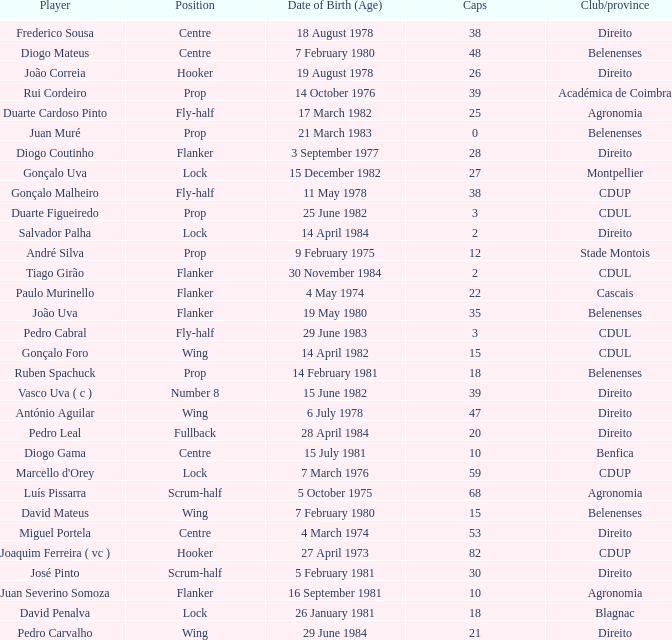Could you parse the entire table? {'header': ['Player', 'Position', 'Date of Birth (Age)', 'Caps', 'Club/province'], 'rows': [['Frederico Sousa', 'Centre', '18 August 1978', '38', 'Direito'], ['Diogo Mateus', 'Centre', '7 February 1980', '48', 'Belenenses'], ['João Correia', 'Hooker', '19 August 1978', '26', 'Direito'], ['Rui Cordeiro', 'Prop', '14 October 1976', '39', 'Académica de Coimbra'], ['Duarte Cardoso Pinto', 'Fly-half', '17 March 1982', '25', 'Agronomia'], ['Juan Muré', 'Prop', '21 March 1983', '0', 'Belenenses'], ['Diogo Coutinho', 'Flanker', '3 September 1977', '28', 'Direito'], ['Gonçalo Uva', 'Lock', '15 December 1982', '27', 'Montpellier'], ['Gonçalo Malheiro', 'Fly-half', '11 May 1978', '38', 'CDUP'], ['Duarte Figueiredo', 'Prop', '25 June 1982', '3', 'CDUL'], ['Salvador Palha', 'Lock', '14 April 1984', '2', 'Direito'], ['André Silva', 'Prop', '9 February 1975', '12', 'Stade Montois'], ['Tiago Girão', 'Flanker', '30 November 1984', '2', 'CDUL'], ['Paulo Murinello', 'Flanker', '4 May 1974', '22', 'Cascais'], ['João Uva', 'Flanker', '19 May 1980', '35', 'Belenenses'], ['Pedro Cabral', 'Fly-half', '29 June 1983', '3', 'CDUL'], ['Gonçalo Foro', 'Wing', '14 April 1982', '15', 'CDUL'], ['Ruben Spachuck', 'Prop', '14 February 1981', '18', 'Belenenses'], ['Vasco Uva ( c )', 'Number 8', '15 June 1982', '39', 'Direito'], ['António Aguilar', 'Wing', '6 July 1978', '47', 'Direito'], ['Pedro Leal', 'Fullback', '28 April 1984', '20', 'Direito'], ['Diogo Gama', 'Centre', '15 July 1981', '10', 'Benfica'], ["Marcello d'Orey", 'Lock', '7 March 1976', '59', 'CDUP'], ['Luís Pissarra', 'Scrum-half', '5 October 1975', '68', 'Agronomia'], ['David Mateus', 'Wing', '7 February 1980', '15', 'Belenenses'], ['Miguel Portela', 'Centre', '4 March 1974', '53', 'Direito'], ['Joaquim Ferreira ( vc )', 'Hooker', '27 April 1973', '82', 'CDUP'], ['José Pinto', 'Scrum-half', '5 February 1981', '30', 'Direito'], ['Juan Severino Somoza', 'Flanker', '16 September 1981', '10', 'Agronomia'], ['David Penalva', 'Lock', '26 January 1981', '18', 'Blagnac'], ['Pedro Carvalho', 'Wing', '29 June 1984', '21', 'Direito']]} Which player has a Position of fly-half, and a Caps of 3? Pedro Cabral. 